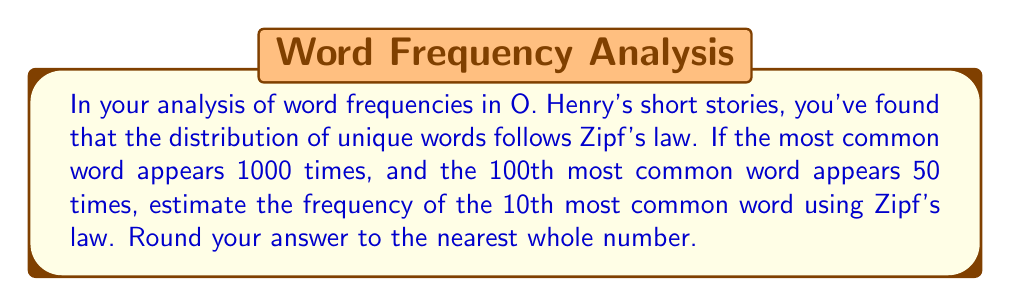Teach me how to tackle this problem. To solve this problem, we'll use Zipf's law and the given information. Let's proceed step-by-step:

1) Zipf's law states that the frequency of a word is inversely proportional to its rank. Mathematically, this can be expressed as:

   $$ f(k) \propto \frac{1}{k^s} $$

   where $f(k)$ is the frequency of the word with rank $k$, and $s$ is a parameter close to 1.

2) We can write this as an equation:

   $$ f(k) = \frac{C}{k^s} $$

   where $C$ is a constant.

3) We're given two data points:
   - For $k=1$, $f(1) = 1000$
   - For $k=100$, $f(100) = 50$

4) Let's use these to find $s$:

   $$ \frac{f(1)}{f(100)} = \frac{1000}{50} = 20 = 100^s $$

5) Taking the logarithm of both sides:

   $$ \log 20 = s \log 100 $$
   $$ s = \frac{\log 20}{\log 100} \approx 0.65 $$

6) Now we can find $C$ using either data point. Let's use $k=1$:

   $$ 1000 = \frac{C}{1^{0.65}} $$
   $$ C = 1000 $$

7) Now we can estimate the frequency of the 10th most common word:

   $$ f(10) = \frac{1000}{10^{0.65}} \approx 223.87 $$

8) Rounding to the nearest whole number:

   $$ f(10) \approx 224 $$
Answer: 224 